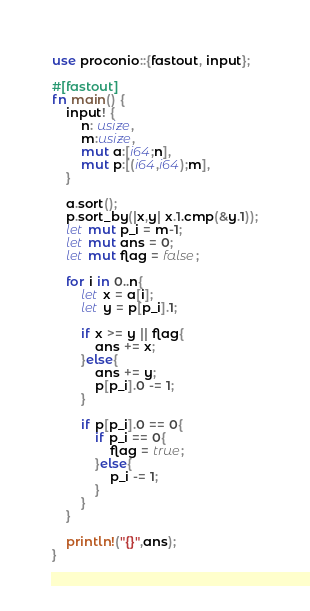<code> <loc_0><loc_0><loc_500><loc_500><_Rust_>use proconio::{fastout, input};

#[fastout]
fn main() {
    input! {
        n: usize,
        m:usize,
        mut a:[i64;n],
        mut p:[(i64,i64);m],
    }

    a.sort();
    p.sort_by(|x,y| x.1.cmp(&y.1));
    let mut p_i = m-1;
    let mut ans = 0;
    let mut flag = false;

    for i in 0..n{
        let x = a[i];
        let y = p[p_i].1;

        if x >= y || flag{
            ans += x;
        }else{
            ans += y;
            p[p_i].0 -= 1;
        }

        if p[p_i].0 == 0{
            if p_i == 0{
                flag = true;
            }else{
                p_i -= 1;
            }
        }
    }

    println!("{}",ans);
}
</code> 